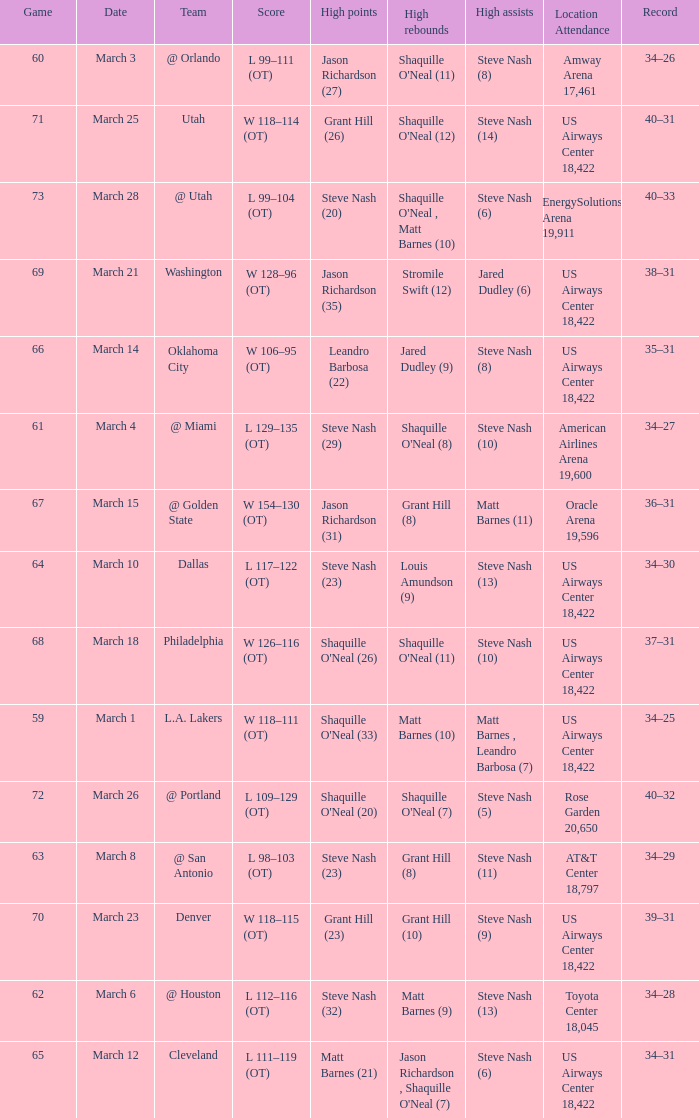After the March 15 game, what was the team's record? 36–31. 